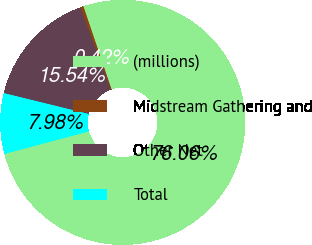Convert chart. <chart><loc_0><loc_0><loc_500><loc_500><pie_chart><fcel>(millions)<fcel>Midstream Gathering and<fcel>Other Net<fcel>Total<nl><fcel>76.06%<fcel>0.42%<fcel>15.54%<fcel>7.98%<nl></chart> 